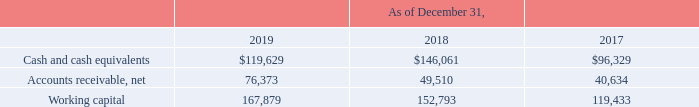Liquidity and Capital Resources
Working Capital
The following table summarizes our cash and cash equivalents, accounts receivable, net and working capital, for the periods indicated (in thousands):
We define working capital as current assets minus current liabilities. Our cash and cash equivalents as of December 31, 2019 are available for working capital purposes. We do not enter into investments for trading purposes, and our investment policy is to invest any excess cash in short term, highly liquid investments that limit the risk of principal loss; therefore, our cash and cash equivalents are held in demand deposit accounts that generate very low returns.
How did the company define working capital? Current assets minus current liabilities. What was the working capital in 2019?
Answer scale should be: thousand. 167,879. Which years does the table provide information for the company's cash and cash equivalents, accounts receivable, net and working capital for? 2019, 2018, 2017. What was the change in working capital between 2017 and 2018?
Answer scale should be: thousand. 152,793-119,433
Answer: 33360. How many years did net accounts receivables exceed $50,000 thousand? 2019
Answer: 1. What was the percentage change in Cash and cash equivalents between 2018 and 2019?
Answer scale should be: percent. (119,629-146,061)/146,061
Answer: -18.1. 